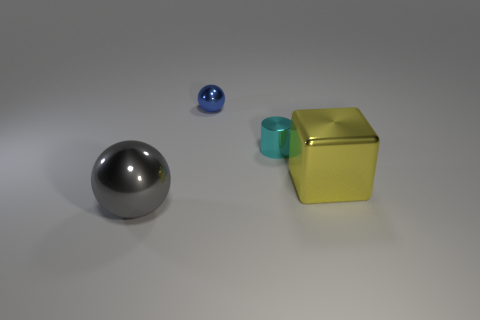Add 3 tiny objects. How many objects exist? 7 Subtract all cylinders. How many objects are left? 3 Add 2 large brown spheres. How many large brown spheres exist? 2 Subtract 1 yellow blocks. How many objects are left? 3 Subtract all tiny yellow blocks. Subtract all yellow metallic objects. How many objects are left? 3 Add 1 large spheres. How many large spheres are left? 2 